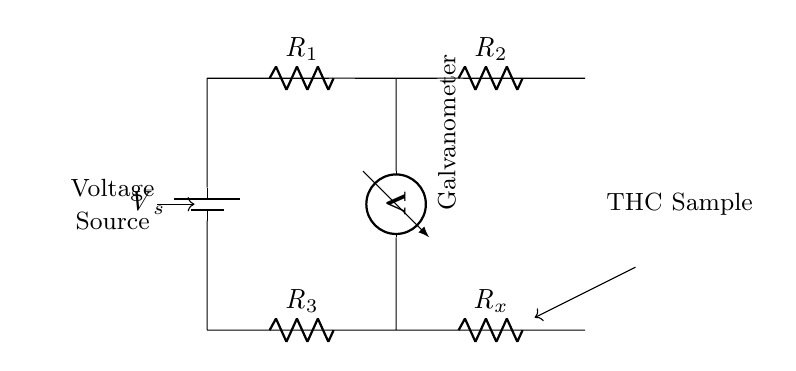What type of circuit is depicted? The circuit shown is a Wheatstone bridge, which is used to measure resistance. It consists of four resistors arranged in a diamond shape and is used for precision measurement.
Answer: Wheatstone bridge What do R1 and R2 represent? R1 and R2 are resistors in the Wheatstone bridge configuration. They are part of the voltage divider that helps measure the unknown resistance by comparing it to known resistances.
Answer: Resistors What is the role of the galvanometer? The galvanometer measures the voltage difference between the midpoint of the resistors R1 and R2, indicating if the bridge is balanced or not, hence helping to determine the unknown resistance (Rx).
Answer: Voltage measurement How many resistors are present in this circuit? There are four resistors total: R1, R2, R3, and the unknown resistor Rx. They are necessary for balancing the bridge and measuring the sample resistance accurately.
Answer: Four What variable does Rx represent? Rx is the unknown resistance that represents the resistance corresponding to the THC content in the cannabis sample being measured. It is the variable we are trying to find.
Answer: THC content resistance What is the purpose of the voltage source in this circuit? The voltage source, denoted as Vs, provides the necessary electrical energy to establish a current in the circuit, which enables the voltage measurement across the galvanometer.
Answer: To supply power 